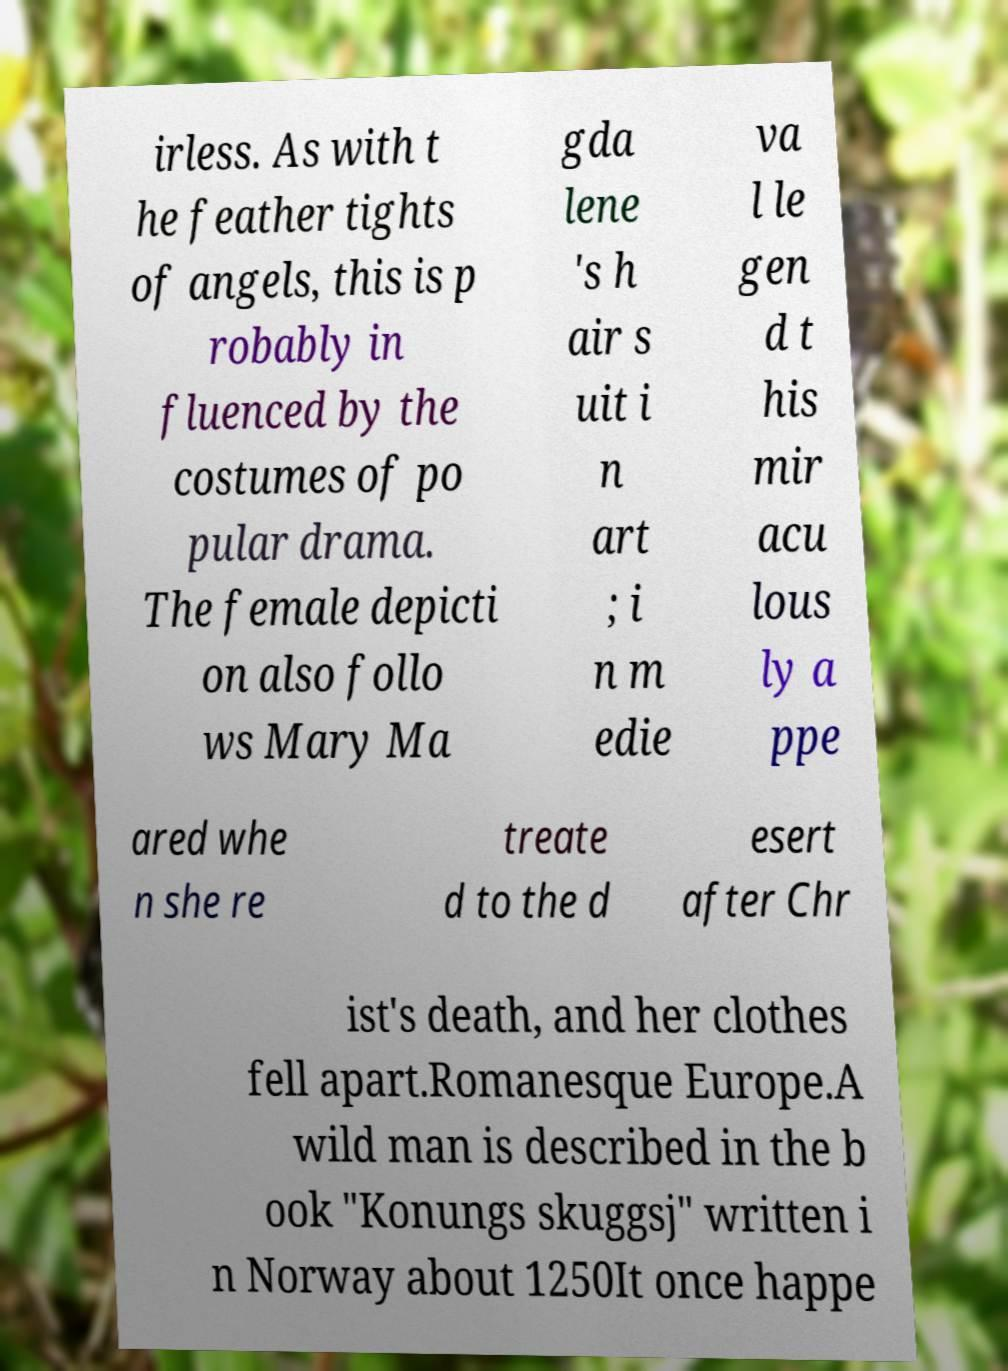Please identify and transcribe the text found in this image. irless. As with t he feather tights of angels, this is p robably in fluenced by the costumes of po pular drama. The female depicti on also follo ws Mary Ma gda lene 's h air s uit i n art ; i n m edie va l le gen d t his mir acu lous ly a ppe ared whe n she re treate d to the d esert after Chr ist's death, and her clothes fell apart.Romanesque Europe.A wild man is described in the b ook "Konungs skuggsj" written i n Norway about 1250It once happe 